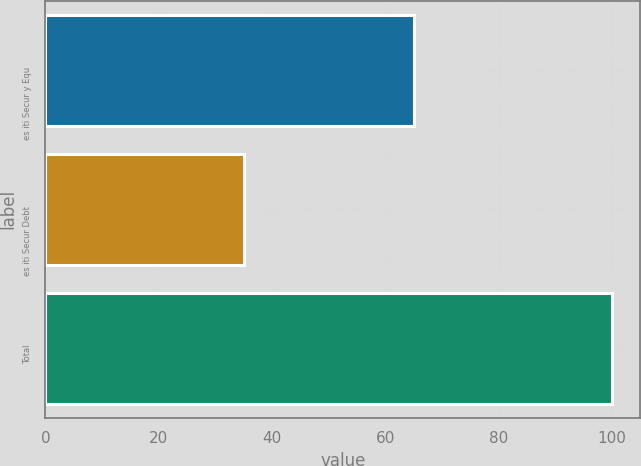Convert chart. <chart><loc_0><loc_0><loc_500><loc_500><bar_chart><fcel>es iti Secur y Equ<fcel>es iti Secur Debt<fcel>Total<nl><fcel>65<fcel>35<fcel>100<nl></chart> 